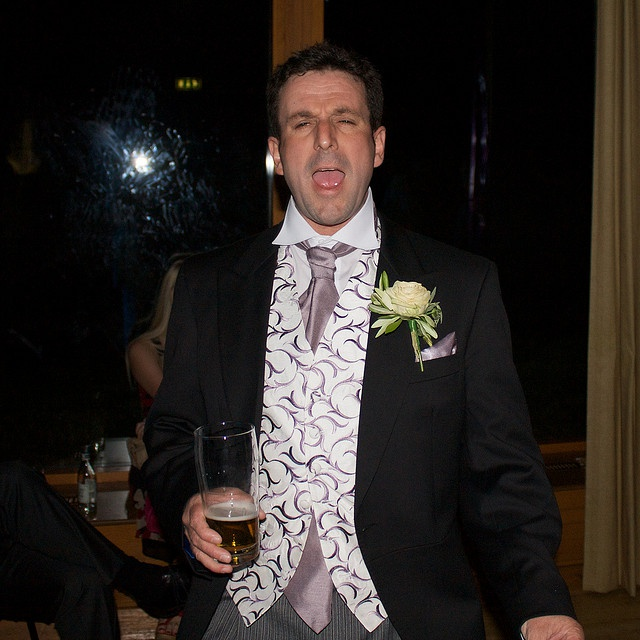Describe the objects in this image and their specific colors. I can see people in black, lightgray, brown, and darkgray tones, people in black, maroon, and purple tones, cup in black, darkgray, and gray tones, tie in black, darkgray, and gray tones, and people in black and maroon tones in this image. 